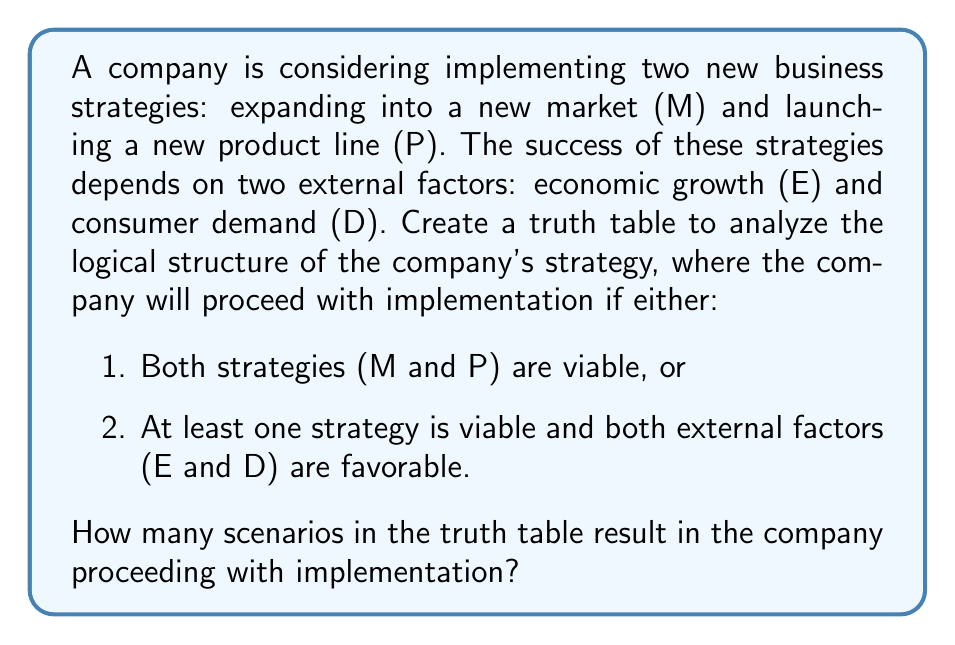Provide a solution to this math problem. To solve this problem, we need to create a truth table and analyze the logical structure of the given conditions. Let's break it down step by step:

1. Identify the variables:
   M: Expanding into a new market
   P: Launching a new product line
   E: Economic growth
   D: Consumer demand

2. Create the truth table with these variables:

   | M | P | E | D | (M ∧ P) | (E ∧ D) | (M ∨ P) | Result |
   |---|---|---|---|---------|---------|---------|--------|
   | 0 | 0 | 0 | 0 |    0    |    0    |    0    |   0    |
   | 0 | 0 | 0 | 1 |    0    |    0    |    0    |   0    |
   | 0 | 0 | 1 | 0 |    0    |    0    |    0    |   0    |
   | 0 | 0 | 1 | 1 |    0    |    1    |    0    |   0    |
   | 0 | 1 | 0 | 0 |    0    |    0    |    1    |   0    |
   | 0 | 1 | 0 | 1 |    0    |    0    |    1    |   0    |
   | 0 | 1 | 1 | 0 |    0    |    0    |    1    |   0    |
   | 0 | 1 | 1 | 1 |    0    |    1    |    1    |   1    |
   | 1 | 0 | 0 | 0 |    0    |    0    |    1    |   0    |
   | 1 | 0 | 0 | 1 |    0    |    0    |    1    |   0    |
   | 1 | 0 | 1 | 0 |    0    |    0    |    1    |   0    |
   | 1 | 0 | 1 | 1 |    0    |    1    |    1    |   1    |
   | 1 | 1 | 0 | 0 |    1    |    0    |    1    |   1    |
   | 1 | 1 | 0 | 1 |    1    |    0    |    1    |   1    |
   | 1 | 1 | 1 | 0 |    1    |    0    |    1    |   1    |
   | 1 | 1 | 1 | 1 |    1    |    1    |    1    |   1    |

3. The logical expression for the company to proceed with implementation is:
   $$(M \land P) \lor ((M \lor P) \land (E \land D))$$

4. Analyze each row of the truth table:
   - The company proceeds when (M ∧ P) is true (last 4 rows)
   - The company also proceeds when (M ∨ P) is true AND (E ∧ D) is true (rows 8 and 12)

5. Count the number of scenarios where the Result is 1:
   There are 6 scenarios where the Result is 1, indicating that the company will proceed with implementation.
Answer: There are 6 scenarios in the truth table that result in the company proceeding with implementation. 